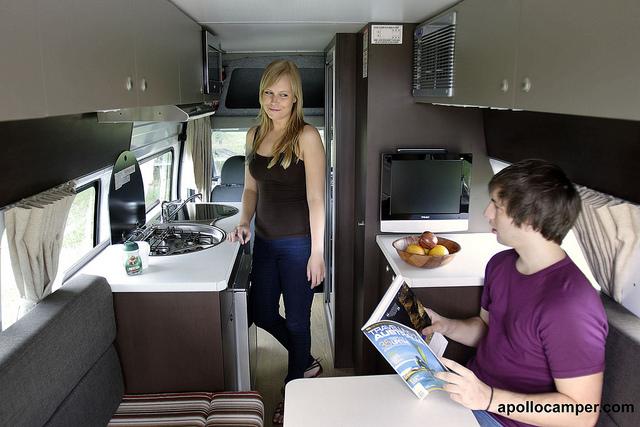What emotion is the woman displaying?
Quick response, please. Happy. Which person is wearing a dark string on their wrist?
Answer briefly. Man. Is the person standing up a man or woman?
Answer briefly. Woman. 